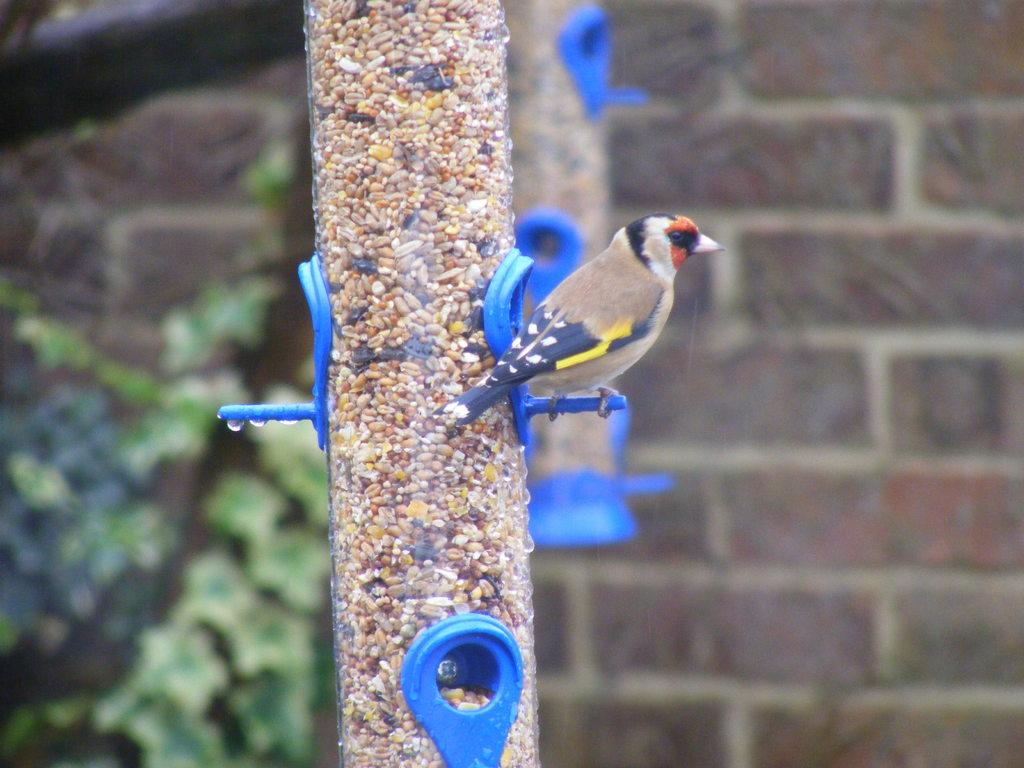What type of animal can be seen in the image? There is a bird in the image. Where is the bird located? The bird is on a tube. What is inside the tube? There is food for the birds in the tube. What can be seen in the background of the image? There is a wall visible in the image. What colors can be observed on the bird? The bird has brown, black, and yellow coloring. What type of shoes is the bird wearing in the image? There are no shoes present in the image, as birds do not wear shoes. What authority figure can be seen in the image? There is no authority figure present in the image; it features a bird on a tube with food. 